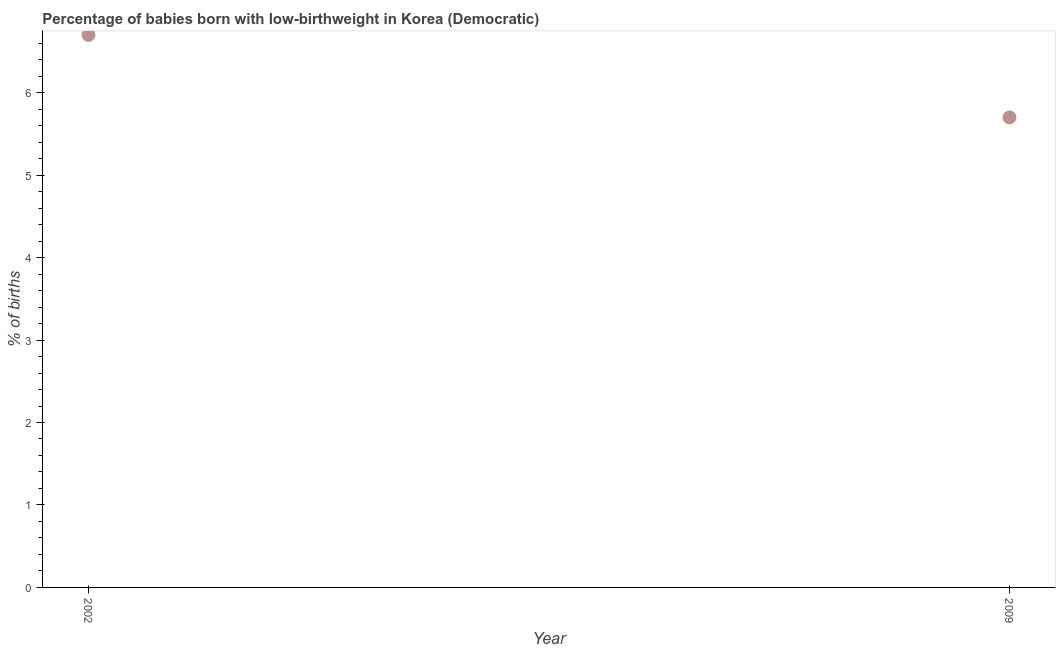Across all years, what is the maximum percentage of babies who were born with low-birthweight?
Give a very brief answer. 6.7. Across all years, what is the minimum percentage of babies who were born with low-birthweight?
Offer a terse response. 5.7. In how many years, is the percentage of babies who were born with low-birthweight greater than 6.4 %?
Your response must be concise. 1. Do a majority of the years between 2009 and 2002 (inclusive) have percentage of babies who were born with low-birthweight greater than 5.6 %?
Offer a very short reply. No. What is the ratio of the percentage of babies who were born with low-birthweight in 2002 to that in 2009?
Ensure brevity in your answer.  1.18. In how many years, is the percentage of babies who were born with low-birthweight greater than the average percentage of babies who were born with low-birthweight taken over all years?
Offer a very short reply. 1. How many dotlines are there?
Provide a short and direct response. 1. How many years are there in the graph?
Provide a succinct answer. 2. What is the difference between two consecutive major ticks on the Y-axis?
Ensure brevity in your answer.  1. Are the values on the major ticks of Y-axis written in scientific E-notation?
Your answer should be very brief. No. Does the graph contain any zero values?
Provide a succinct answer. No. Does the graph contain grids?
Keep it short and to the point. No. What is the title of the graph?
Make the answer very short. Percentage of babies born with low-birthweight in Korea (Democratic). What is the label or title of the Y-axis?
Offer a terse response. % of births. What is the % of births in 2002?
Offer a very short reply. 6.7. What is the % of births in 2009?
Ensure brevity in your answer.  5.7. What is the difference between the % of births in 2002 and 2009?
Make the answer very short. 1. What is the ratio of the % of births in 2002 to that in 2009?
Keep it short and to the point. 1.18. 